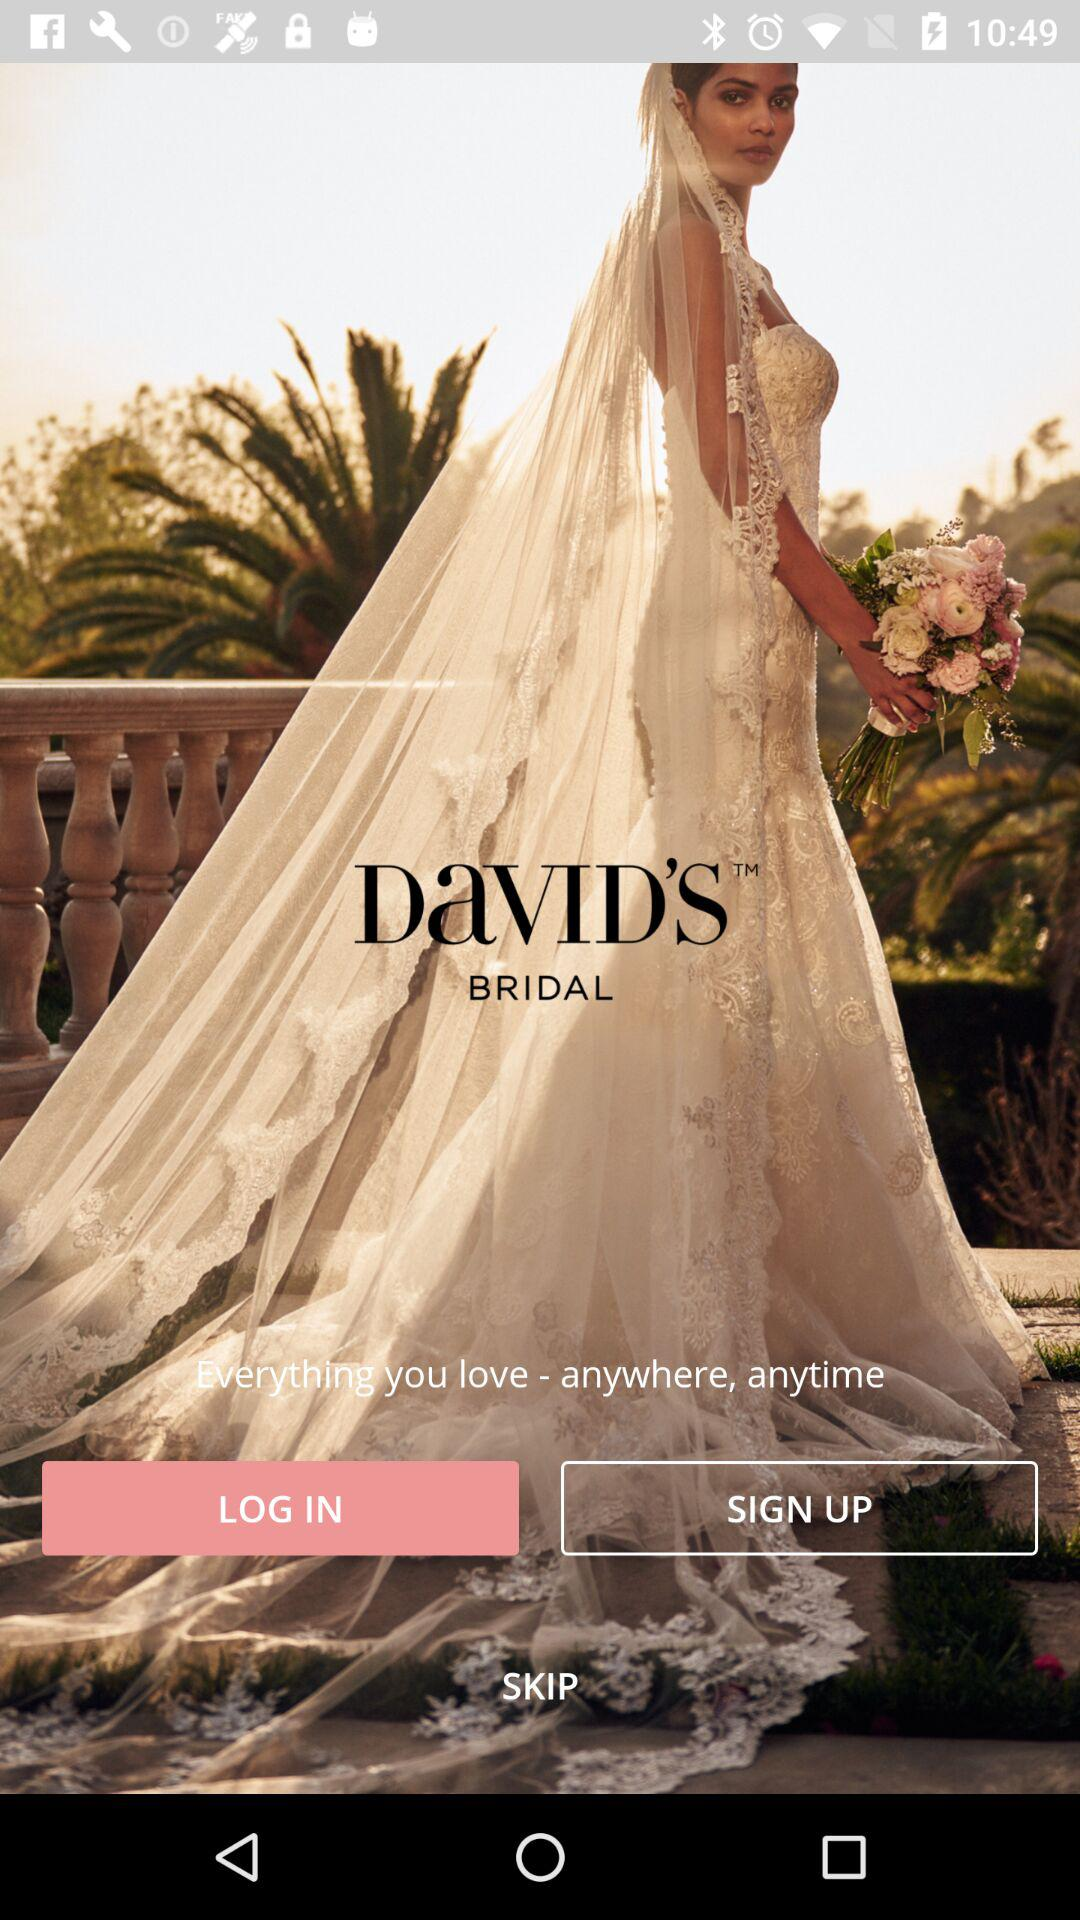What is the application name? The application name is "DaVID'S BRIDAL". 